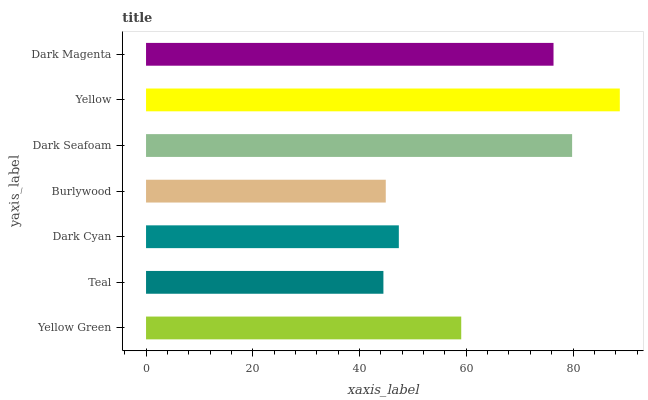Is Teal the minimum?
Answer yes or no. Yes. Is Yellow the maximum?
Answer yes or no. Yes. Is Dark Cyan the minimum?
Answer yes or no. No. Is Dark Cyan the maximum?
Answer yes or no. No. Is Dark Cyan greater than Teal?
Answer yes or no. Yes. Is Teal less than Dark Cyan?
Answer yes or no. Yes. Is Teal greater than Dark Cyan?
Answer yes or no. No. Is Dark Cyan less than Teal?
Answer yes or no. No. Is Yellow Green the high median?
Answer yes or no. Yes. Is Yellow Green the low median?
Answer yes or no. Yes. Is Dark Cyan the high median?
Answer yes or no. No. Is Burlywood the low median?
Answer yes or no. No. 